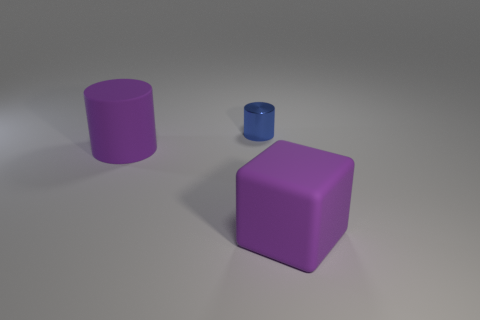Is there any other thing of the same color as the small shiny cylinder?
Keep it short and to the point. No. What shape is the thing that is both on the left side of the purple block and in front of the shiny cylinder?
Your answer should be very brief. Cylinder. Are there an equal number of large blocks that are behind the big purple cylinder and metallic things that are behind the purple cube?
Offer a very short reply. No. How many blocks are either purple rubber things or small blue metallic things?
Your response must be concise. 1. How many other small blue cylinders are the same material as the blue cylinder?
Offer a terse response. 0. There is a matte thing that is the same color as the large cylinder; what shape is it?
Offer a terse response. Cube. There is a thing that is on the right side of the large rubber cylinder and left of the large cube; what is its material?
Keep it short and to the point. Metal. There is a large purple matte thing that is on the right side of the small shiny cylinder; what is its shape?
Offer a very short reply. Cube. There is a large purple rubber thing that is on the right side of the big purple thing on the left side of the purple cube; what is its shape?
Ensure brevity in your answer.  Cube. Is there a matte thing of the same shape as the blue metallic object?
Your response must be concise. Yes. 